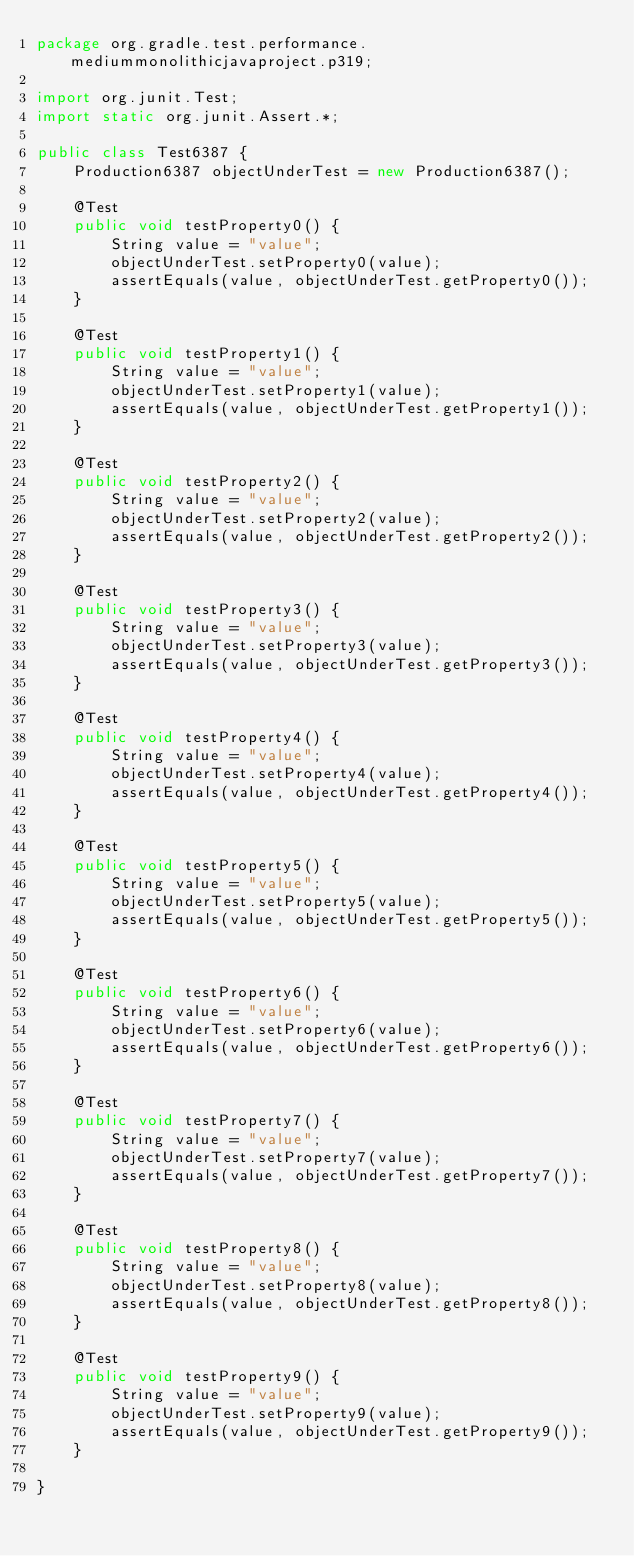Convert code to text. <code><loc_0><loc_0><loc_500><loc_500><_Java_>package org.gradle.test.performance.mediummonolithicjavaproject.p319;

import org.junit.Test;
import static org.junit.Assert.*;

public class Test6387 {  
    Production6387 objectUnderTest = new Production6387();     

    @Test
    public void testProperty0() {
        String value = "value";
        objectUnderTest.setProperty0(value);
        assertEquals(value, objectUnderTest.getProperty0());
    }

    @Test
    public void testProperty1() {
        String value = "value";
        objectUnderTest.setProperty1(value);
        assertEquals(value, objectUnderTest.getProperty1());
    }

    @Test
    public void testProperty2() {
        String value = "value";
        objectUnderTest.setProperty2(value);
        assertEquals(value, objectUnderTest.getProperty2());
    }

    @Test
    public void testProperty3() {
        String value = "value";
        objectUnderTest.setProperty3(value);
        assertEquals(value, objectUnderTest.getProperty3());
    }

    @Test
    public void testProperty4() {
        String value = "value";
        objectUnderTest.setProperty4(value);
        assertEquals(value, objectUnderTest.getProperty4());
    }

    @Test
    public void testProperty5() {
        String value = "value";
        objectUnderTest.setProperty5(value);
        assertEquals(value, objectUnderTest.getProperty5());
    }

    @Test
    public void testProperty6() {
        String value = "value";
        objectUnderTest.setProperty6(value);
        assertEquals(value, objectUnderTest.getProperty6());
    }

    @Test
    public void testProperty7() {
        String value = "value";
        objectUnderTest.setProperty7(value);
        assertEquals(value, objectUnderTest.getProperty7());
    }

    @Test
    public void testProperty8() {
        String value = "value";
        objectUnderTest.setProperty8(value);
        assertEquals(value, objectUnderTest.getProperty8());
    }

    @Test
    public void testProperty9() {
        String value = "value";
        objectUnderTest.setProperty9(value);
        assertEquals(value, objectUnderTest.getProperty9());
    }

}</code> 